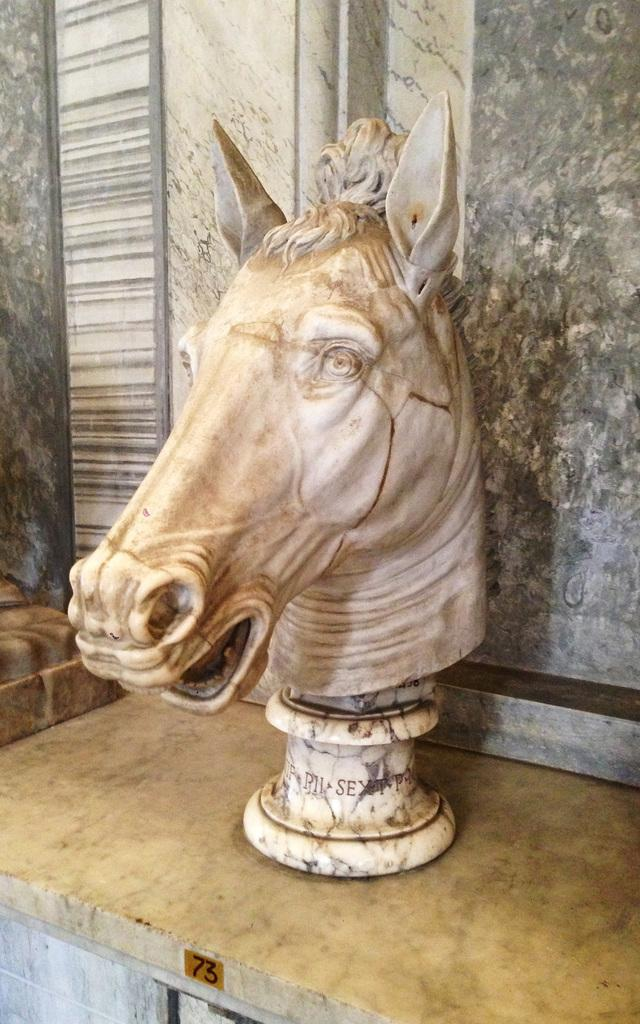What is the main subject of the image? There is a horse sculpture in the image. What type of floor is the horse sculpture placed on? The horse sculpture is on a marble floor. What is the background of the image made of? There is a marble wall behind the sculpture. What word does the horse sculpture spell out in the image? The horse sculpture does not spell out any words in the image; it is a sculpture of a horse. 